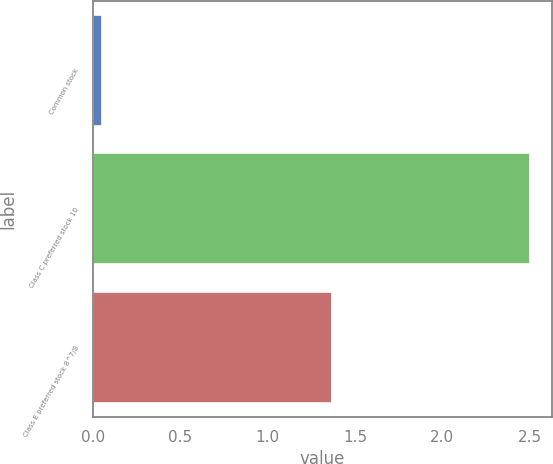Convert chart to OTSL. <chart><loc_0><loc_0><loc_500><loc_500><bar_chart><fcel>Common stock<fcel>Class C preferred stock 10<fcel>Class E preferred stock 8^7/8<nl><fcel>0.05<fcel>2.5<fcel>1.37<nl></chart> 